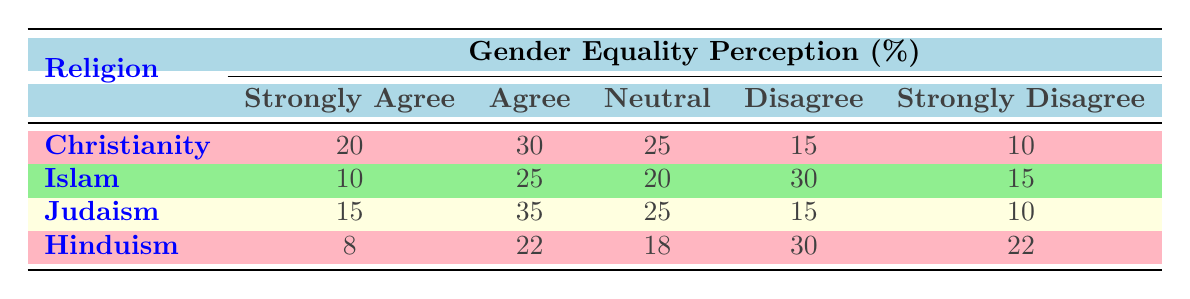What is the percentage of Christians who strongly agree with gender equality? According to the table, the population percentage for Christians who strongly agree with gender equality is specifically stated as 20.
Answer: 20 What is the most common perception of gender equality among Jews? From the table, the most common perception (highest percentage) is "Agree," which is listed at 35 percent for Judaism.
Answer: 35 What is the average percentage of people who disagree with gender equality across all religions? To find the average for the "Disagree" category, sum the percentages for each religion: \( 15 + 30 + 15 + 30 = 90 \). There are 4 data points, so the average is \( 90/4 = 22.5 \).
Answer: 22.5 Is there a larger percentage of Hindus who strongly agree or strongly disagree with gender equality? Hindus have 8 percent for "Strongly Agree" and 22 percent for "Strongly Disagree". Since 22 is greater than 8, it is evident that there is a larger percentage of Hindus who strongly disagree.
Answer: Yes Do more Muslims agree than disagree with gender equality? The agreement categories for Muslims include 10 percent for "Strongly Agree" and 25 percent for "Agree," totaling 35 percent. The disagreement categories show 30 percent disagreeing and 15 percent strongly disagreeing, totaling 45 percent. Since 35 is less than 45, more Muslims disagree than agree.
Answer: No Which religion has the highest percentage of individuals who are neutral about gender equality? Looking through the "Neutral" category, Christianity, Islam, Judaism, and Hinduism show 25, 20, 25, and 18 percent respectively. Both Christianity and Judaism have the highest percentage of 25.
Answer: Christianity and Judaism What is the difference between the percentage of Christians who agree and those who disagree with gender equality? In Christianity, the percentage of those who "Agree" is 30, and those who "Disagree" is 15. The difference is \( 30 - 15 = 15 \).
Answer: 15 Which religion has the lowest percentage of individuals who strongly agree with gender equality? Checking the "Strongly Agree" column, Hindus have the lowest percentage at 8 compared to the other religions.
Answer: Hinduism How many percent of individuals from all religions combined either strongly disagree or disagree with gender equality? To find this, sum the percentages for "Strongly Disagree" and "Disagree" across all religions: \( 10 + 15 + 10 + 22 + 15 + 30 + 15 + 30 + 22 =  10 + 30 + 25 + 22 + 37 =  172 \) total percentage combined for "Disagree" and "Strongly Disagree."
Answer: 172 